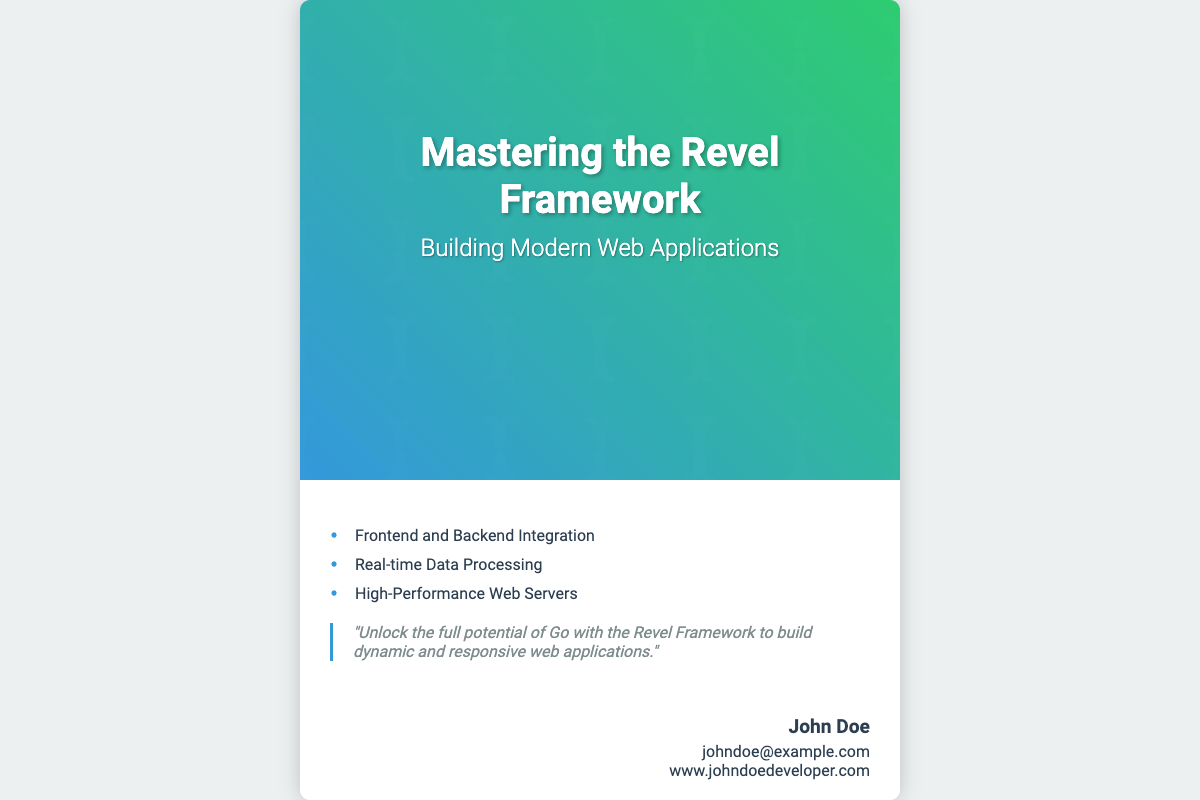what is the title of the book? The title of the book is prominently displayed on the cover as the main title.
Answer: Mastering the Revel Framework who is the author of the book? The author’s name is found in the bottom section of the cover.
Answer: John Doe what is the subtitle of the book? The subtitle is located beneath the main title on the cover.
Answer: Building Modern Web Applications how many bullet points are listed in the content? The bullet points are visible in the content area of the cover.
Answer: 3 what is the main theme of the quote on the cover? The quote emphasizes the benefits of using the framework with Go in web application development.
Answer: Unlock the full potential of Go which technology framework is highlighted on the book cover? The cover specifically mentions a technology framework in the title.
Answer: Revel Framework what color scheme is used in the cover image? The color scheme is evident in the gradient background of the cover image.
Answer: Blue and green what type of applications does the book focus on? The focus of the book is indicated in the subtitle.
Answer: Web Applications 